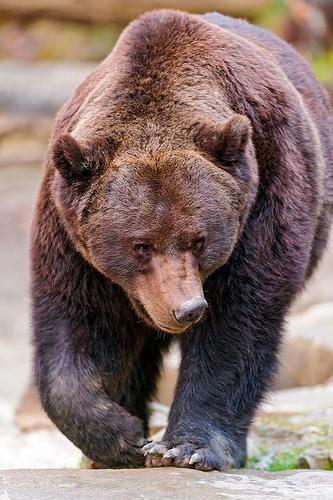How many bears are in the picture?
Give a very brief answer. 1. How many of the bear's eyes are in the picture?
Give a very brief answer. 2. 